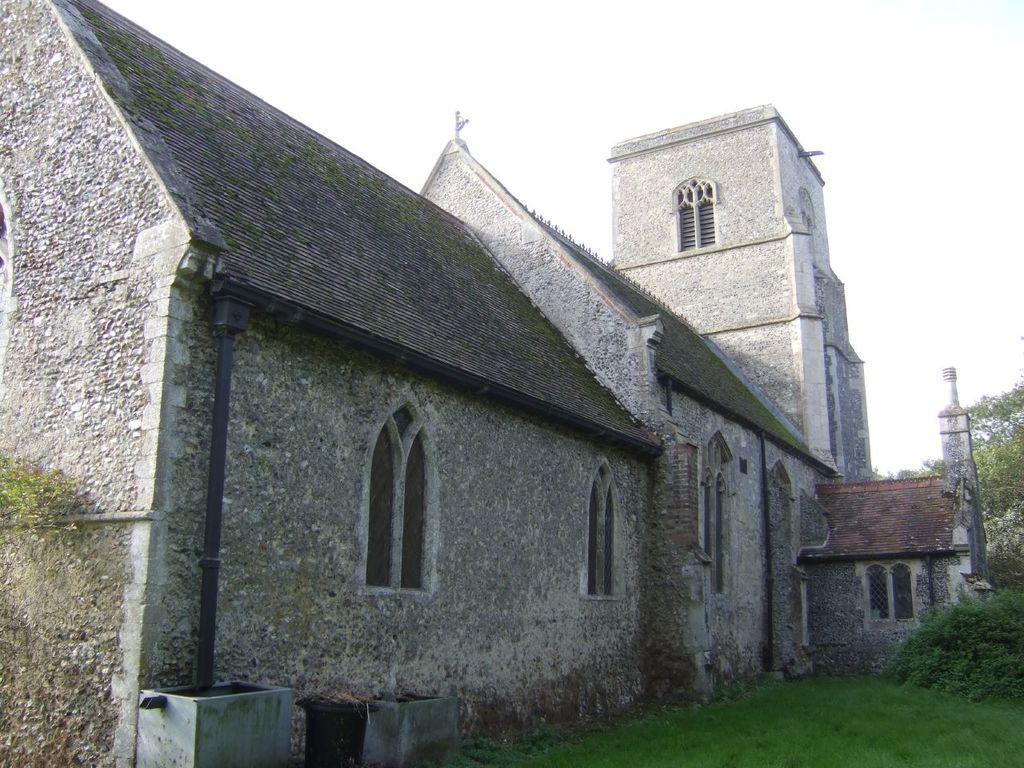Can you describe this image briefly? In the center of the image there is a house. At the top of the image there is sky. At the bottom of the image there is grass. To the right side of the image there is a tree. 